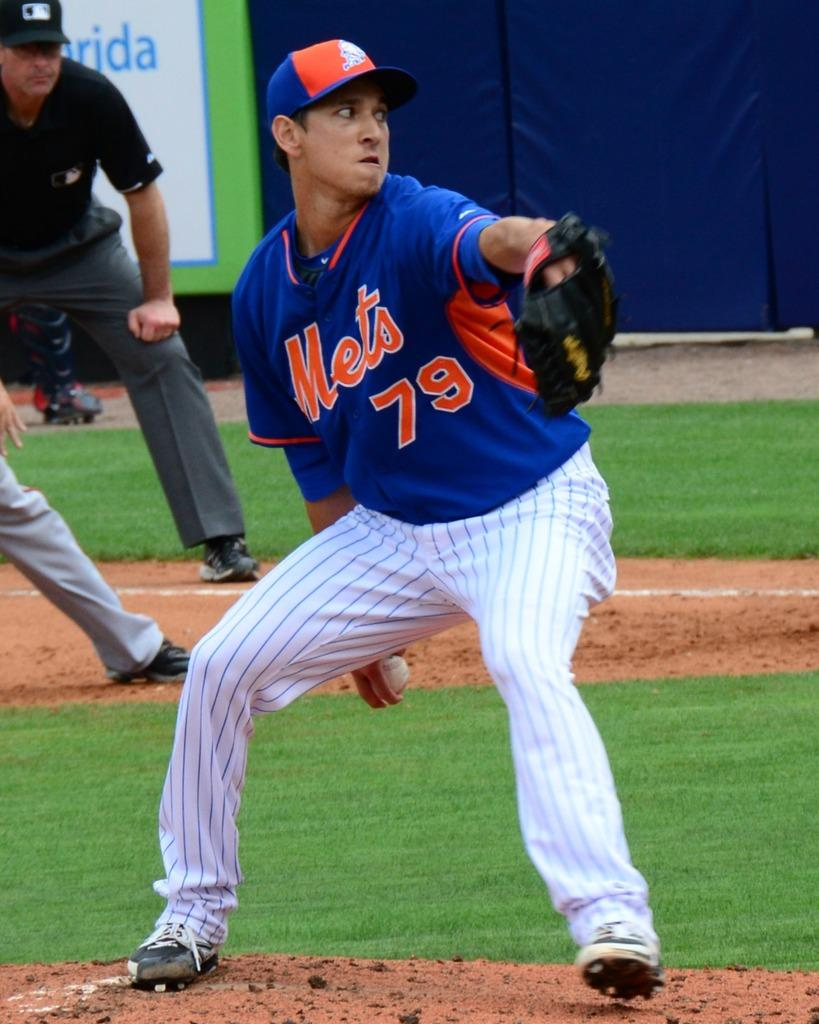<image>
Give a short and clear explanation of the subsequent image. Mets pitcher number 79 is about to pitch the ball. 